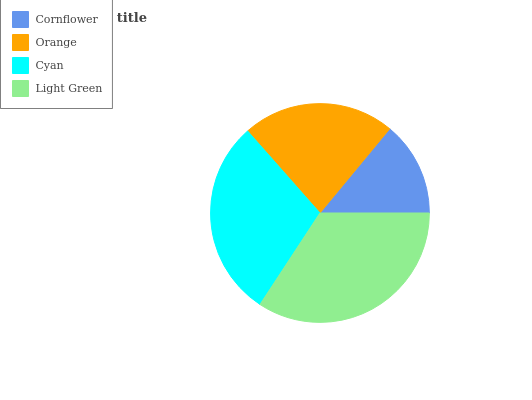Is Cornflower the minimum?
Answer yes or no. Yes. Is Light Green the maximum?
Answer yes or no. Yes. Is Orange the minimum?
Answer yes or no. No. Is Orange the maximum?
Answer yes or no. No. Is Orange greater than Cornflower?
Answer yes or no. Yes. Is Cornflower less than Orange?
Answer yes or no. Yes. Is Cornflower greater than Orange?
Answer yes or no. No. Is Orange less than Cornflower?
Answer yes or no. No. Is Cyan the high median?
Answer yes or no. Yes. Is Orange the low median?
Answer yes or no. Yes. Is Light Green the high median?
Answer yes or no. No. Is Light Green the low median?
Answer yes or no. No. 